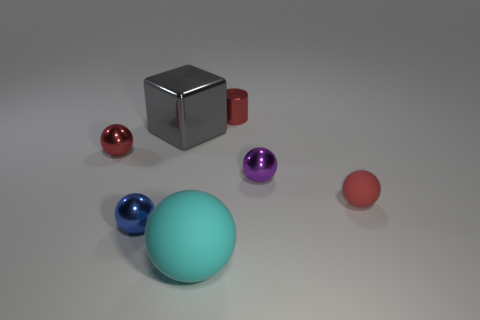There is a matte thing behind the large matte object; does it have the same size as the red metal thing that is behind the big gray metallic cube?
Offer a very short reply. Yes. How big is the red object that is both on the left side of the tiny red rubber thing and on the right side of the cyan object?
Offer a terse response. Small. What is the color of the other large rubber thing that is the same shape as the purple thing?
Give a very brief answer. Cyan. Is the number of large objects behind the cyan object greater than the number of tiny rubber objects that are behind the small red matte ball?
Provide a short and direct response. Yes. What number of other objects are there of the same shape as the tiny matte object?
Your answer should be very brief. 4. Is there a tiny thing behind the small red object to the left of the large rubber object?
Keep it short and to the point. Yes. How many large purple matte blocks are there?
Ensure brevity in your answer.  0. There is a cylinder; does it have the same color as the tiny shiny thing on the left side of the blue object?
Offer a terse response. Yes. Is the number of tiny blue objects greater than the number of yellow rubber cubes?
Provide a short and direct response. Yes. Are there any other things that are the same color as the block?
Your answer should be compact. No. 